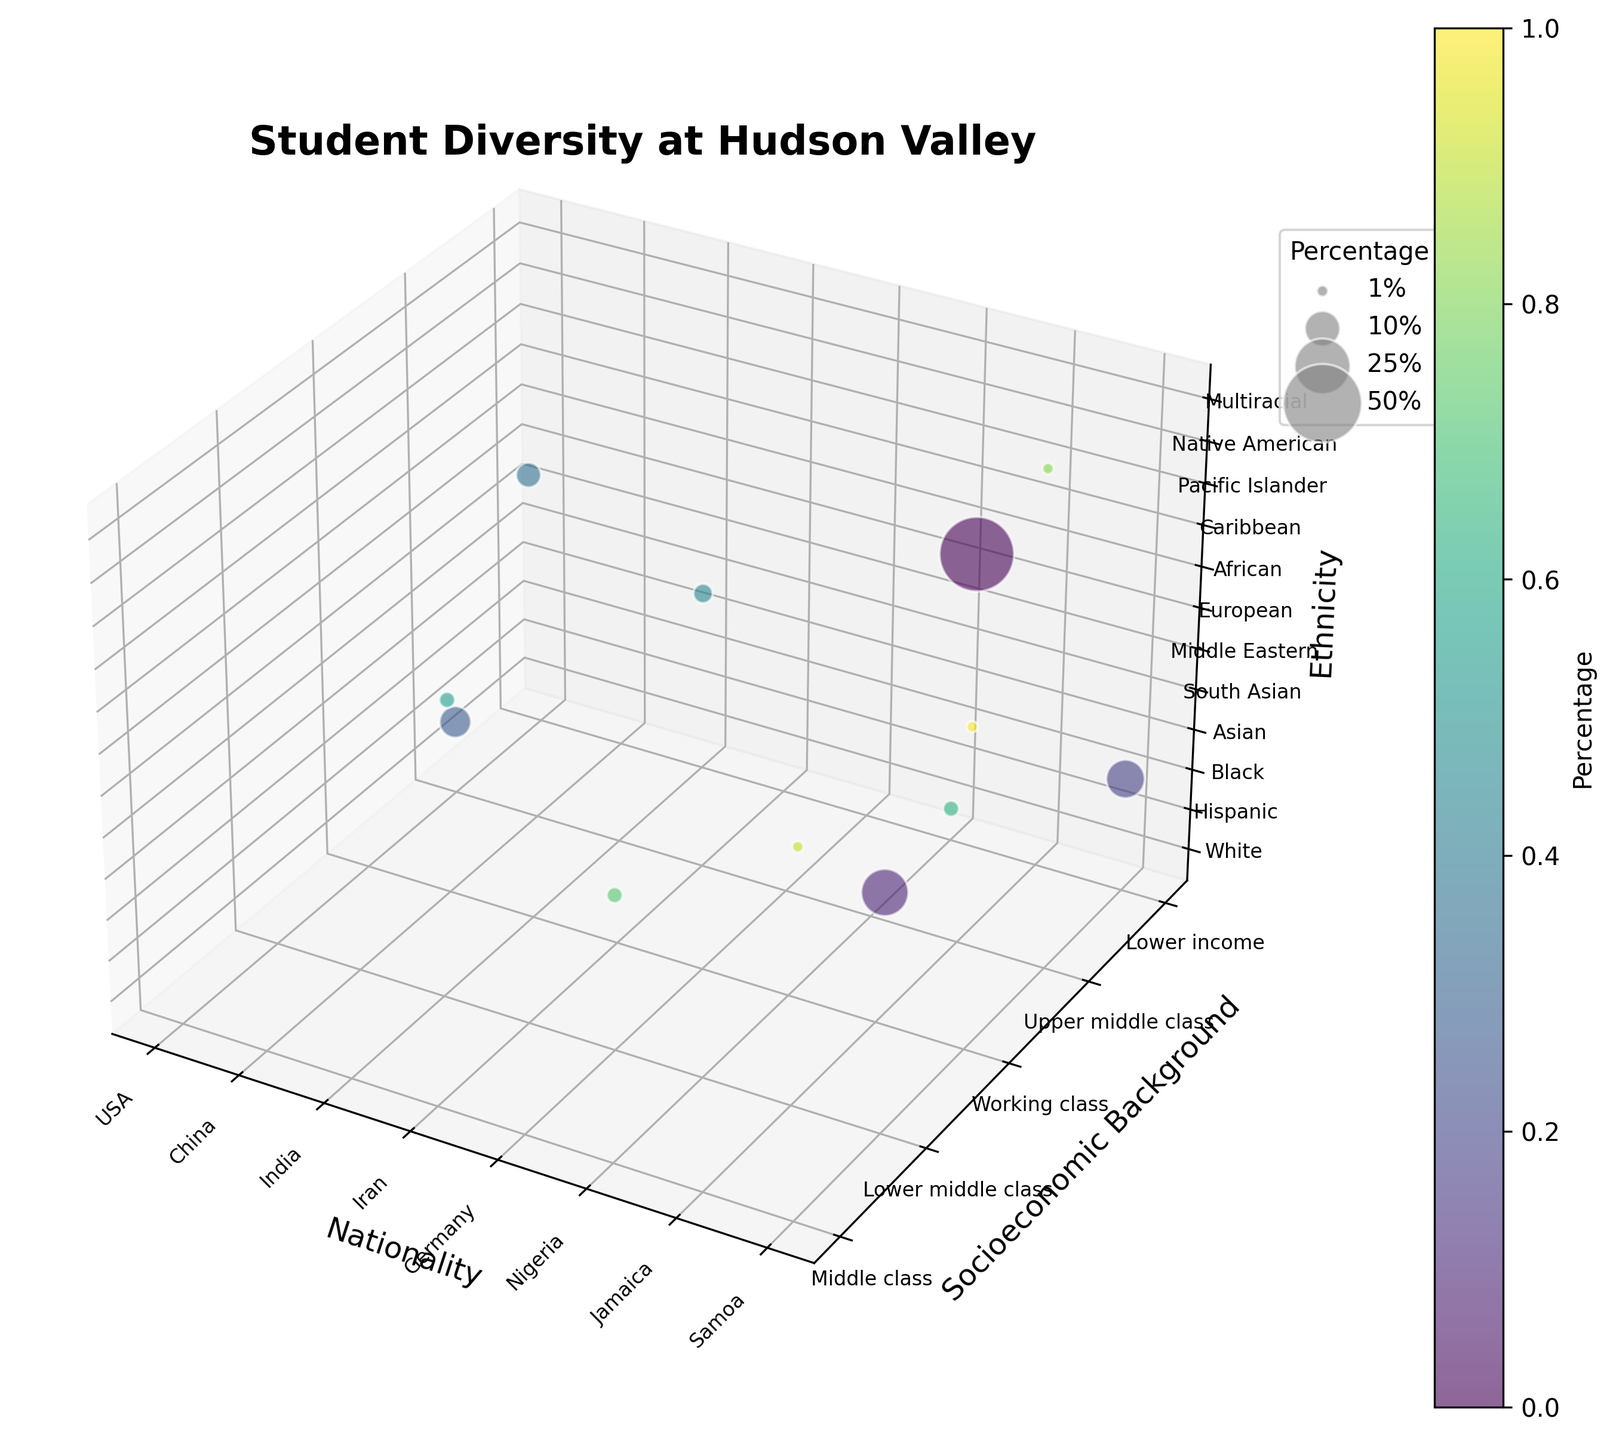How many unique ethnicities are represented in the plot? Count the unique labels along the Z-axis (ethnicity).
Answer: 12 Which nationality has the highest percentage of students? Observe the largest bubble along the X-axis (nationality). The USA has the largest bubble with 45%.
Answer: USA What socioeconomic backgrounds are most common? Check the Y-axis for ticks with the most occurrences. "Middle class" occurs most often.
Answer: Middle class Which ethnic group has the smallest percentage representation? Identify the smallest bubble along the Z-axis (ethnicity). It indicates who has the lowest percentage.
Answer: Native American, Multiracial How does the average percentage of USA students compare to the total average? Calculate the average for USA-related bubbles and compare it to the overall average. Average of USA (ethnicities: White, Hispanic, Black, Native American, Multiracial = (45+18+12+1+1)/5 = 15.4%), overall average = 100/12 = 8.33%.
Answer: USA students have a higher average percentage (15.4% vs 8.33%) Which two ethnic groups have similar representation percentages? Look for bubbles of similar size along the Z-axis. "European" and "African" both have 2%.
Answer: European, African What are the labels of the axes? Check the text labels on the X, Y, and Z axes. X: Nationality, Y: Socioeconomic Background, Z: Ethnicity
Answer: Nationality, Socioeconomic Background, Ethnicity How dispersed are the nationalities in terms of socioeconomic background? Look at the spread of bubbles along the Y-axis for different X-axis values. There is a wide dispersion with nationalities distributed across several socioeconomic backgrounds.
Answer: Wide dispersion What color represents the highest percentage? Check the color of the largest bubble and match it to the colorbar legend.
Answer: Dark purple How many ethnic groups fall within the "Middle class" socioeconomic background? Count the number of bubbles aligned with the "Middle class" label on the Y-axis. They are White, South Asian, European, Multiracial - total 4.
Answer: 4 